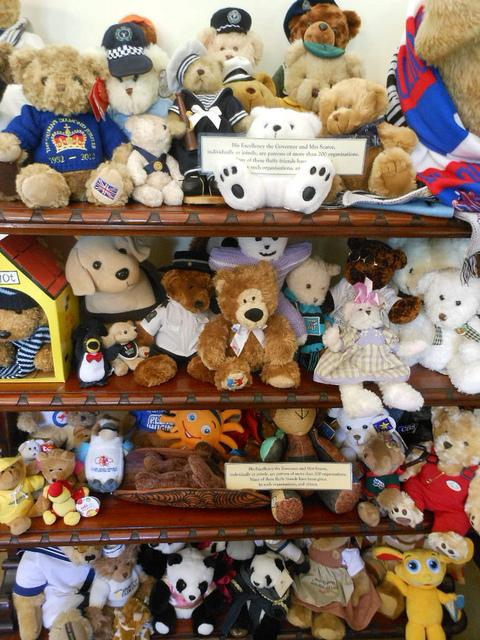What does the person who owns the shelves like to collect?

Choices:
A) stuffed animals
B) clothing
C) books
D) games stuffed animals 